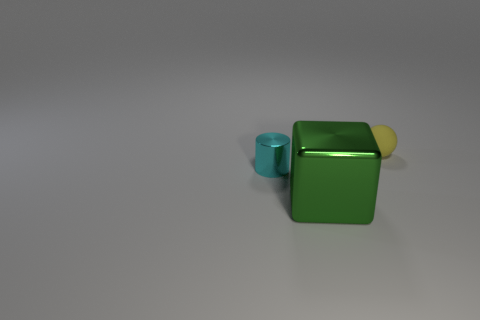How many other things are the same shape as the green shiny object?
Give a very brief answer. 0. Is the number of cyan cylinders that are behind the small cylinder greater than the number of big blocks?
Provide a short and direct response. No. The shiny thing that is behind the big thing is what color?
Ensure brevity in your answer.  Cyan. What number of metallic objects are either yellow things or large gray things?
Provide a succinct answer. 0. There is a small thing on the right side of the metal object behind the green cube; are there any cyan metal things on the right side of it?
Provide a succinct answer. No. There is a small yellow rubber object; what number of tiny shiny cylinders are in front of it?
Your answer should be compact. 1. What number of small things are green metallic blocks or cyan things?
Provide a succinct answer. 1. The thing that is right of the green cube has what shape?
Provide a succinct answer. Sphere. Is there a small object that has the same color as the shiny block?
Provide a short and direct response. No. There is a cyan object behind the green block; does it have the same size as the thing that is behind the tiny cyan metal object?
Offer a very short reply. Yes. 